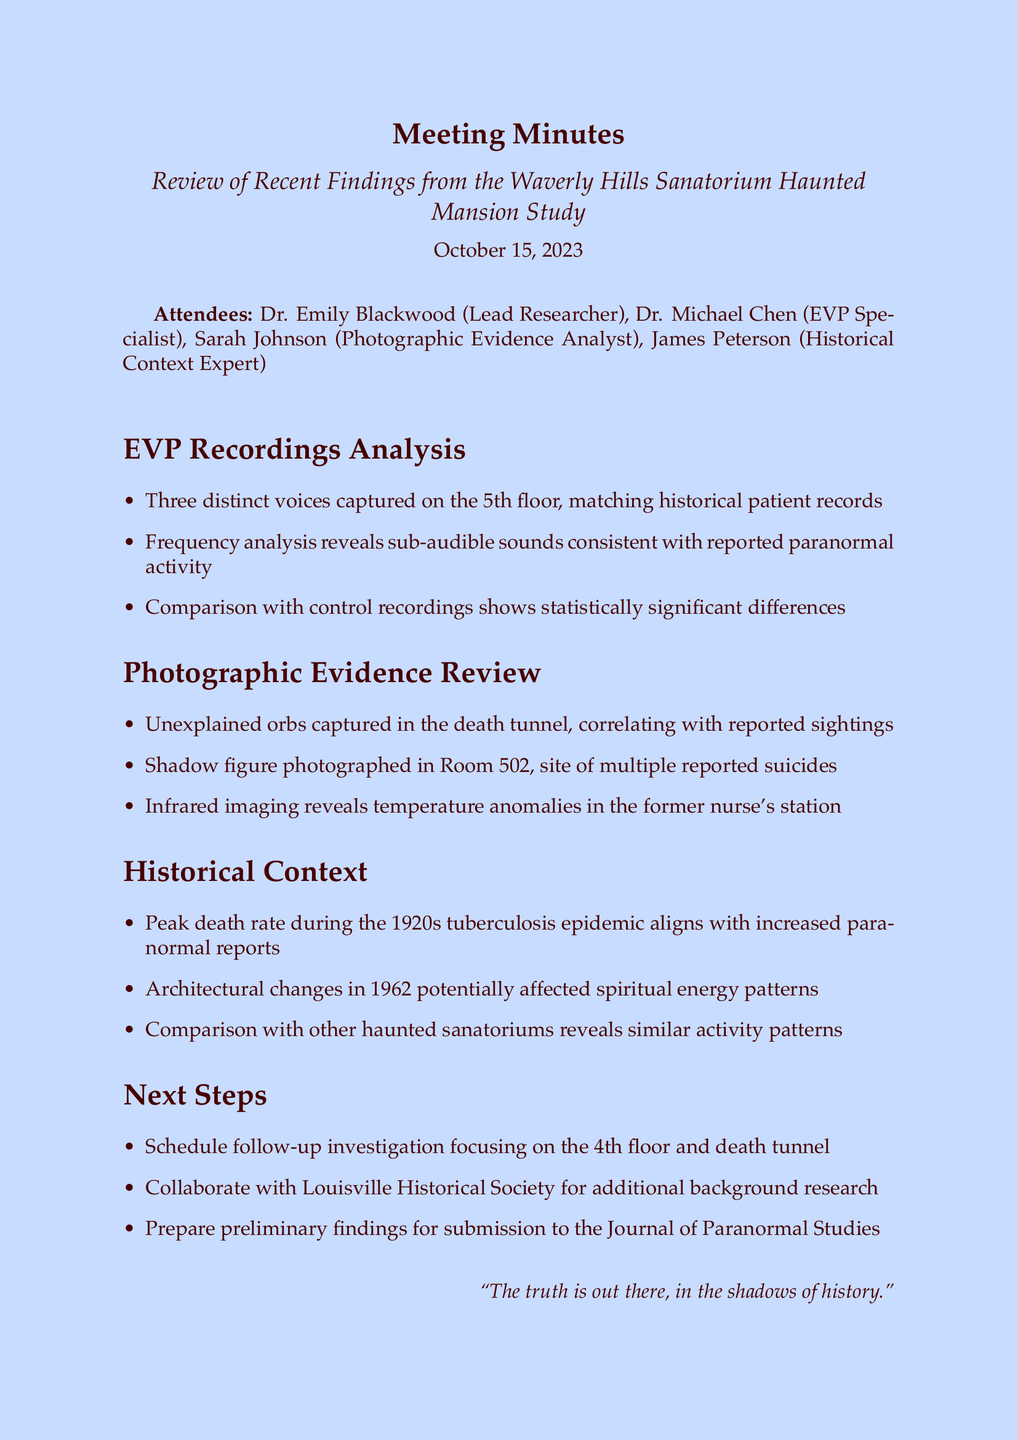What is the meeting title? The meeting title is stated at the beginning of the document, which is "Review of Recent Findings from the Waverly Hills Sanatorium Haunted Mansion Study."
Answer: Review of Recent Findings from the Waverly Hills Sanatorium Haunted Mansion Study Who analyzed the EVP recordings? The document lists attendees, and Dr. Michael Chen is identified as the EVP Specialist, responsible for the analysis of EVP recordings.
Answer: Dr. Michael Chen What date was the meeting held? The date of the meeting is mentioned directly in the document as "October 15, 2023."
Answer: October 15, 2023 How many distinct voices were captured on the 5th floor? In the EVP Recordings Analysis section, it is stated that three distinct voices were captured on the 5th floor.
Answer: Three What significant statistical finding was mentioned regarding the control recordings? The document notes that there are statistically significant differences when comparing EVP recordings with control recordings.
Answer: Statistically significant differences What location had unexplained orbs captured in photographs? The Photographic Evidence Review specifies that unexplained orbs were captured in the death tunnel.
Answer: Death tunnel What time period aligns with increased paranormal reports? The Historical Context section identifies that the peak death rate during the 1920s tuberculosis epidemic correlates with increased paranormal reports.
Answer: 1920s What is the next step regarding the 4th floor? The Next Steps section indicates that a follow-up investigation focusing on the 4th floor is scheduled.
Answer: Follow-up investigation Who is suggested for collaboration on background research? The document mentions collaboration with the Louisville Historical Society for additional background research.
Answer: Louisville Historical Society 